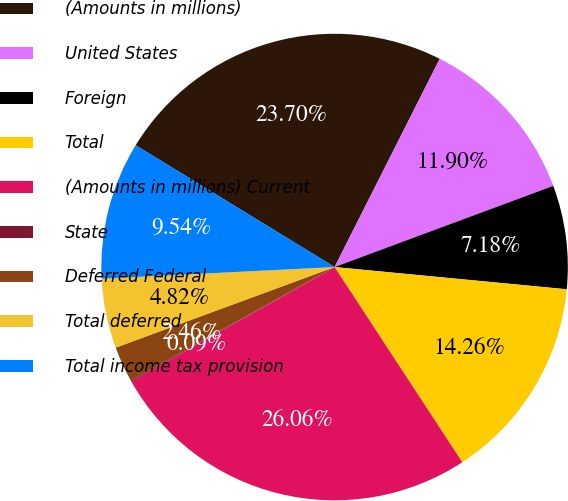Convert chart. <chart><loc_0><loc_0><loc_500><loc_500><pie_chart><fcel>(Amounts in millions)<fcel>United States<fcel>Foreign<fcel>Total<fcel>(Amounts in millions) Current<fcel>State<fcel>Deferred Federal<fcel>Total deferred<fcel>Total income tax provision<nl><fcel>23.7%<fcel>11.9%<fcel>7.18%<fcel>14.26%<fcel>26.06%<fcel>0.09%<fcel>2.46%<fcel>4.82%<fcel>9.54%<nl></chart> 